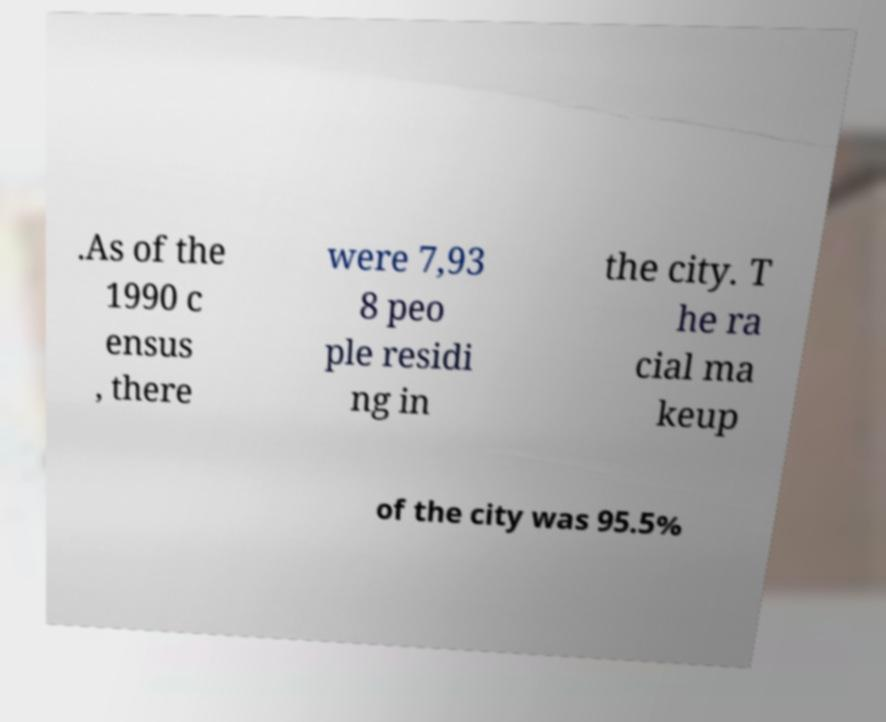What messages or text are displayed in this image? I need them in a readable, typed format. .As of the 1990 c ensus , there were 7,93 8 peo ple residi ng in the city. T he ra cial ma keup of the city was 95.5% 